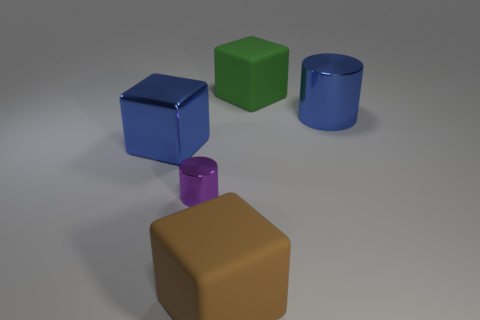Add 4 tiny matte objects. How many objects exist? 9 Subtract all cubes. How many objects are left? 2 Add 3 purple metallic things. How many purple metallic things are left? 4 Add 3 big green things. How many big green things exist? 4 Subtract 0 yellow cylinders. How many objects are left? 5 Subtract all big gray cylinders. Subtract all blue metallic cubes. How many objects are left? 4 